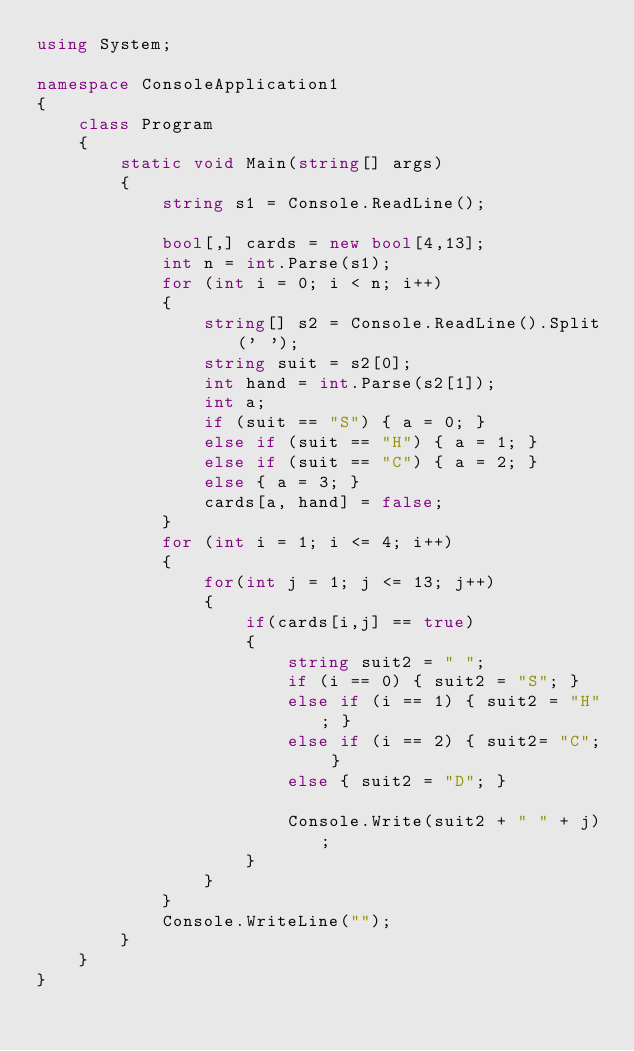<code> <loc_0><loc_0><loc_500><loc_500><_C#_>using System;

namespace ConsoleApplication1
{
    class Program
    {
        static void Main(string[] args)
        {
            string s1 = Console.ReadLine(); 

            bool[,] cards = new bool[4,13];
            int n = int.Parse(s1);
            for (int i = 0; i < n; i++)
            {
                string[] s2 = Console.ReadLine().Split(' ');
                string suit = s2[0];
                int hand = int.Parse(s2[1]);
                int a;
                if (suit == "S") { a = 0; }
                else if (suit == "H") { a = 1; }
                else if (suit == "C") { a = 2; }
                else { a = 3; }
                cards[a, hand] = false;
            }
            for (int i = 1; i <= 4; i++)
            {
                for(int j = 1; j <= 13; j++)
                {
                    if(cards[i,j] == true)
                    {
                        string suit2 = " ";
                        if (i == 0) { suit2 = "S"; }
                        else if (i == 1) { suit2 = "H"; }
                        else if (i == 2) { suit2= "C"; }
                        else { suit2 = "D"; }

                        Console.Write(suit2 + " " + j);
                    }
                }
            }
            Console.WriteLine("");
        }
    }
}</code> 